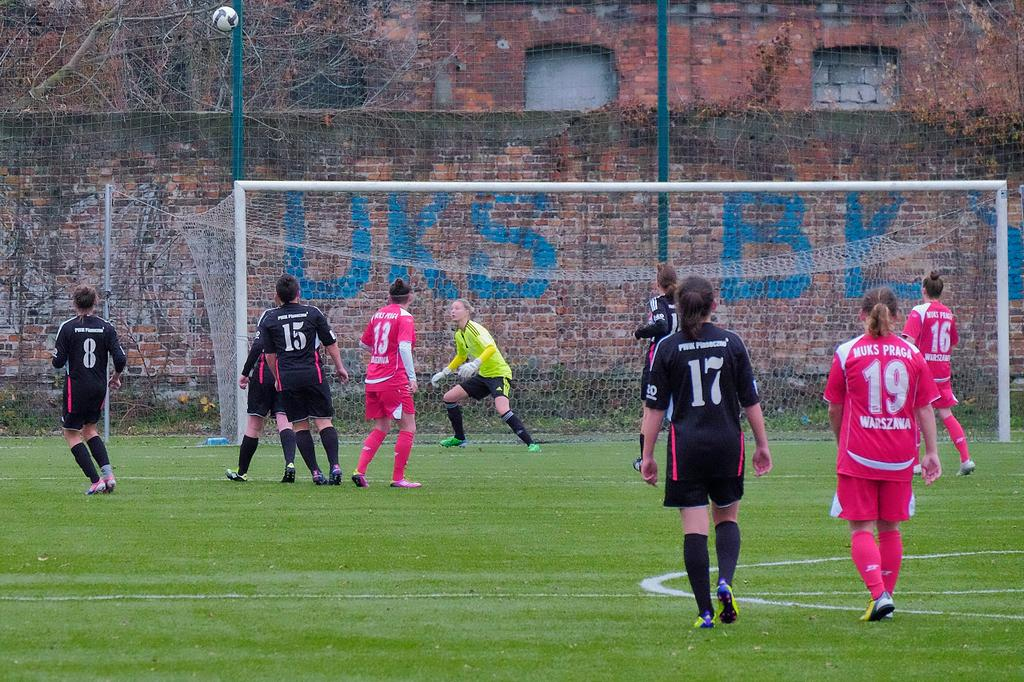<image>
Describe the image concisely. Players 17 and 19 are farther from the goal than everyone else. 